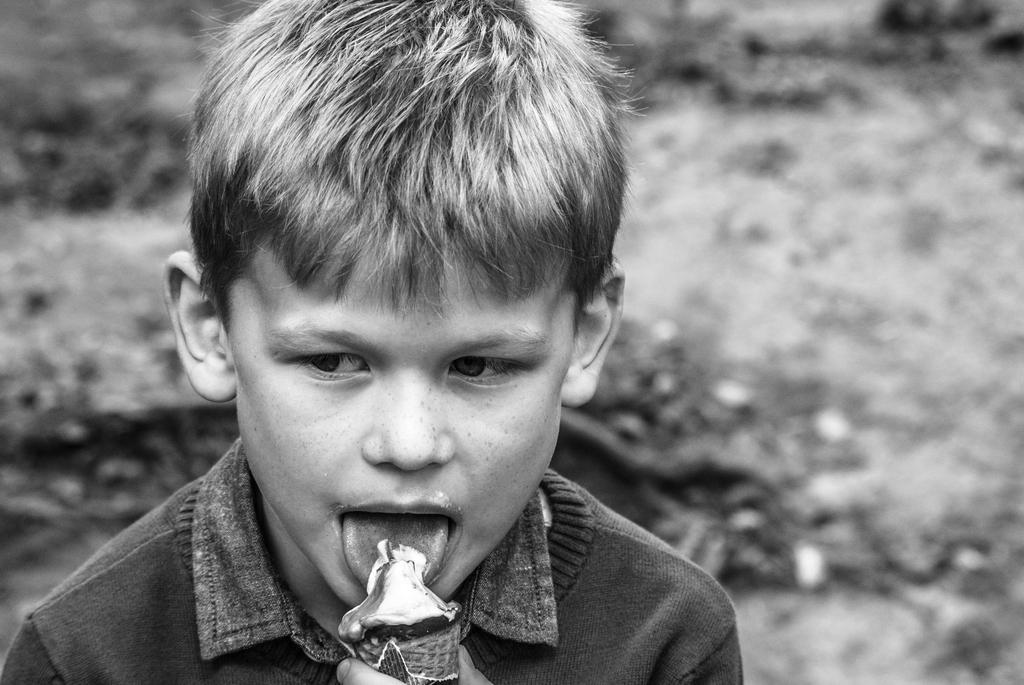Please provide a concise description of this image. As we can see in the image in the front there is a boy eating ice cream and the background is blurred. 